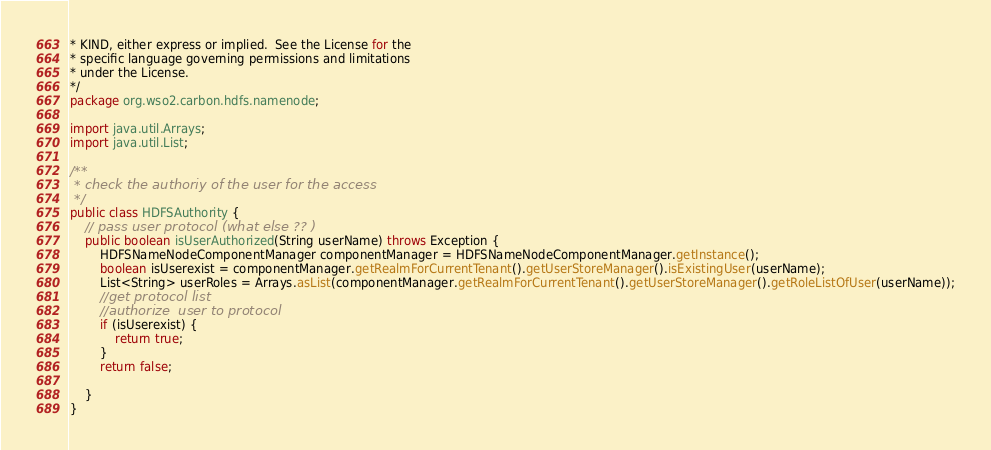Convert code to text. <code><loc_0><loc_0><loc_500><loc_500><_Java_>* KIND, either express or implied.  See the License for the
* specific language governing permissions and limitations
* under the License.
*/
package org.wso2.carbon.hdfs.namenode;

import java.util.Arrays;
import java.util.List;

/**
 * check the authoriy of the user for the access
 */
public class HDFSAuthority {
    // pass user protocol (what else ?? )
    public boolean isUserAuthorized(String userName) throws Exception {
        HDFSNameNodeComponentManager componentManager = HDFSNameNodeComponentManager.getInstance();
        boolean isUserexist = componentManager.getRealmForCurrentTenant().getUserStoreManager().isExistingUser(userName);
        List<String> userRoles = Arrays.asList(componentManager.getRealmForCurrentTenant().getUserStoreManager().getRoleListOfUser(userName));
        //get protocol list
        //authorize  user to protocol
        if (isUserexist) {
            return true;
        }
        return false;

    }
}
</code> 